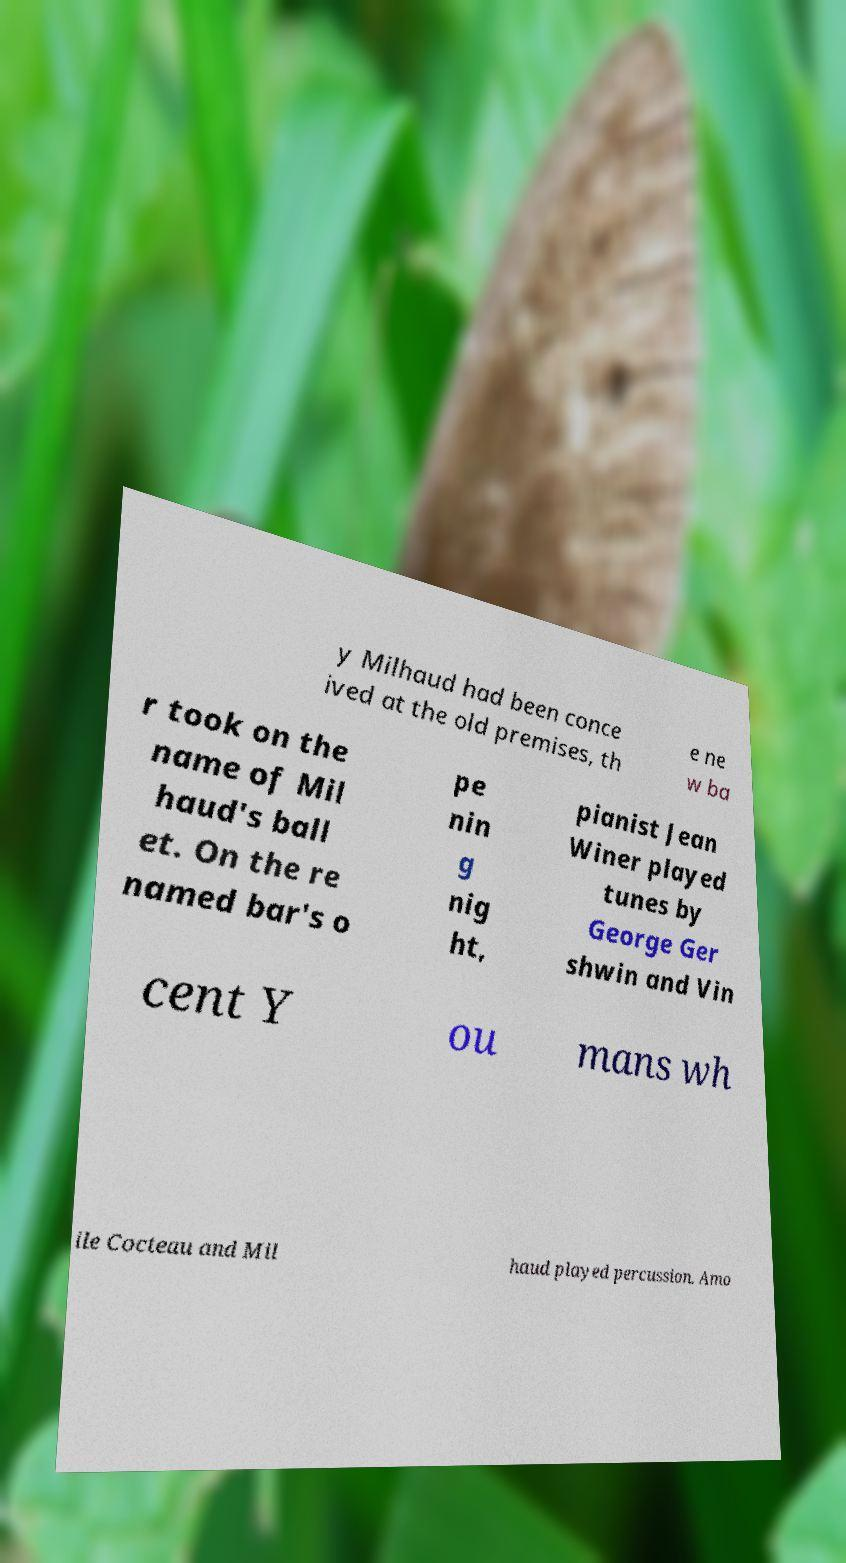Can you accurately transcribe the text from the provided image for me? y Milhaud had been conce ived at the old premises, th e ne w ba r took on the name of Mil haud's ball et. On the re named bar's o pe nin g nig ht, pianist Jean Winer played tunes by George Ger shwin and Vin cent Y ou mans wh ile Cocteau and Mil haud played percussion. Amo 